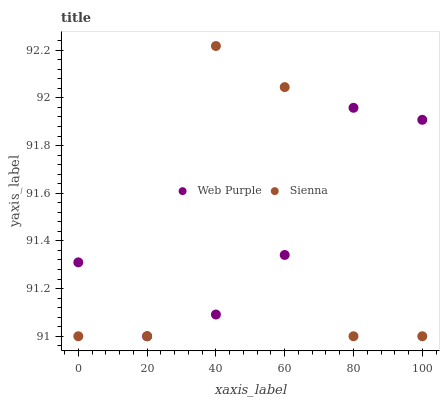Does Web Purple have the minimum area under the curve?
Answer yes or no. Yes. Does Sienna have the maximum area under the curve?
Answer yes or no. Yes. Does Web Purple have the maximum area under the curve?
Answer yes or no. No. Is Web Purple the smoothest?
Answer yes or no. Yes. Is Sienna the roughest?
Answer yes or no. Yes. Is Web Purple the roughest?
Answer yes or no. No. Does Sienna have the lowest value?
Answer yes or no. Yes. Does Sienna have the highest value?
Answer yes or no. Yes. Does Web Purple have the highest value?
Answer yes or no. No. Does Sienna intersect Web Purple?
Answer yes or no. Yes. Is Sienna less than Web Purple?
Answer yes or no. No. Is Sienna greater than Web Purple?
Answer yes or no. No. 